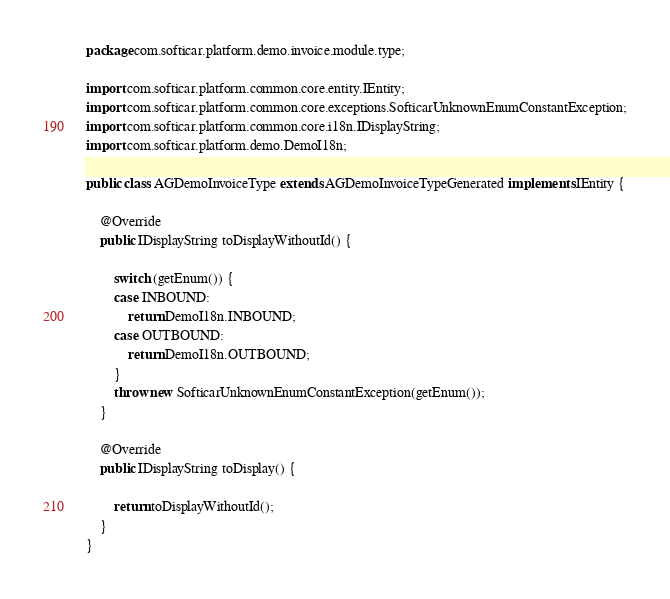Convert code to text. <code><loc_0><loc_0><loc_500><loc_500><_Java_>package com.softicar.platform.demo.invoice.module.type;

import com.softicar.platform.common.core.entity.IEntity;
import com.softicar.platform.common.core.exceptions.SofticarUnknownEnumConstantException;
import com.softicar.platform.common.core.i18n.IDisplayString;
import com.softicar.platform.demo.DemoI18n;

public class AGDemoInvoiceType extends AGDemoInvoiceTypeGenerated implements IEntity {

	@Override
	public IDisplayString toDisplayWithoutId() {

		switch (getEnum()) {
		case INBOUND:
			return DemoI18n.INBOUND;
		case OUTBOUND:
			return DemoI18n.OUTBOUND;
		}
		throw new SofticarUnknownEnumConstantException(getEnum());
	}

	@Override
	public IDisplayString toDisplay() {

		return toDisplayWithoutId();
	}
}
</code> 